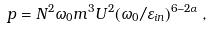Convert formula to latex. <formula><loc_0><loc_0><loc_500><loc_500>p = N ^ { 2 } \omega _ { 0 } m ^ { 3 } U ^ { 2 } ( \omega _ { 0 } / \varepsilon _ { i n } ) ^ { 6 - 2 \alpha } \, ,</formula> 